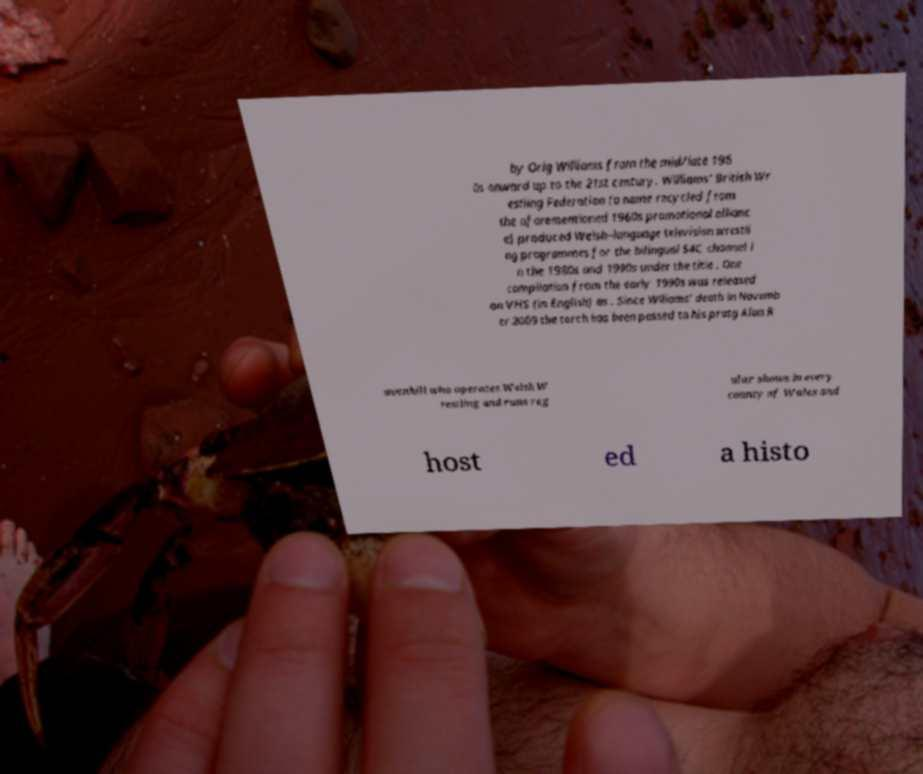Could you assist in decoding the text presented in this image and type it out clearly? by Orig Williams from the mid/late 196 0s onward up to the 21st century. Williams' British Wr estling Federation (a name recycled from the aforementioned 1960s promotional allianc e) produced Welsh–language television wrestli ng programmes for the bilingual S4C channel i n the 1980s and 1990s under the title . One compilation from the early 1990s was released on VHS (in English) as . Since Wlliams' death in Novemb er 2009 the torch has been passed to his protg Alan R avenhill who operates Welsh W restling and runs reg ular shows in every county of Wales and host ed a histo 